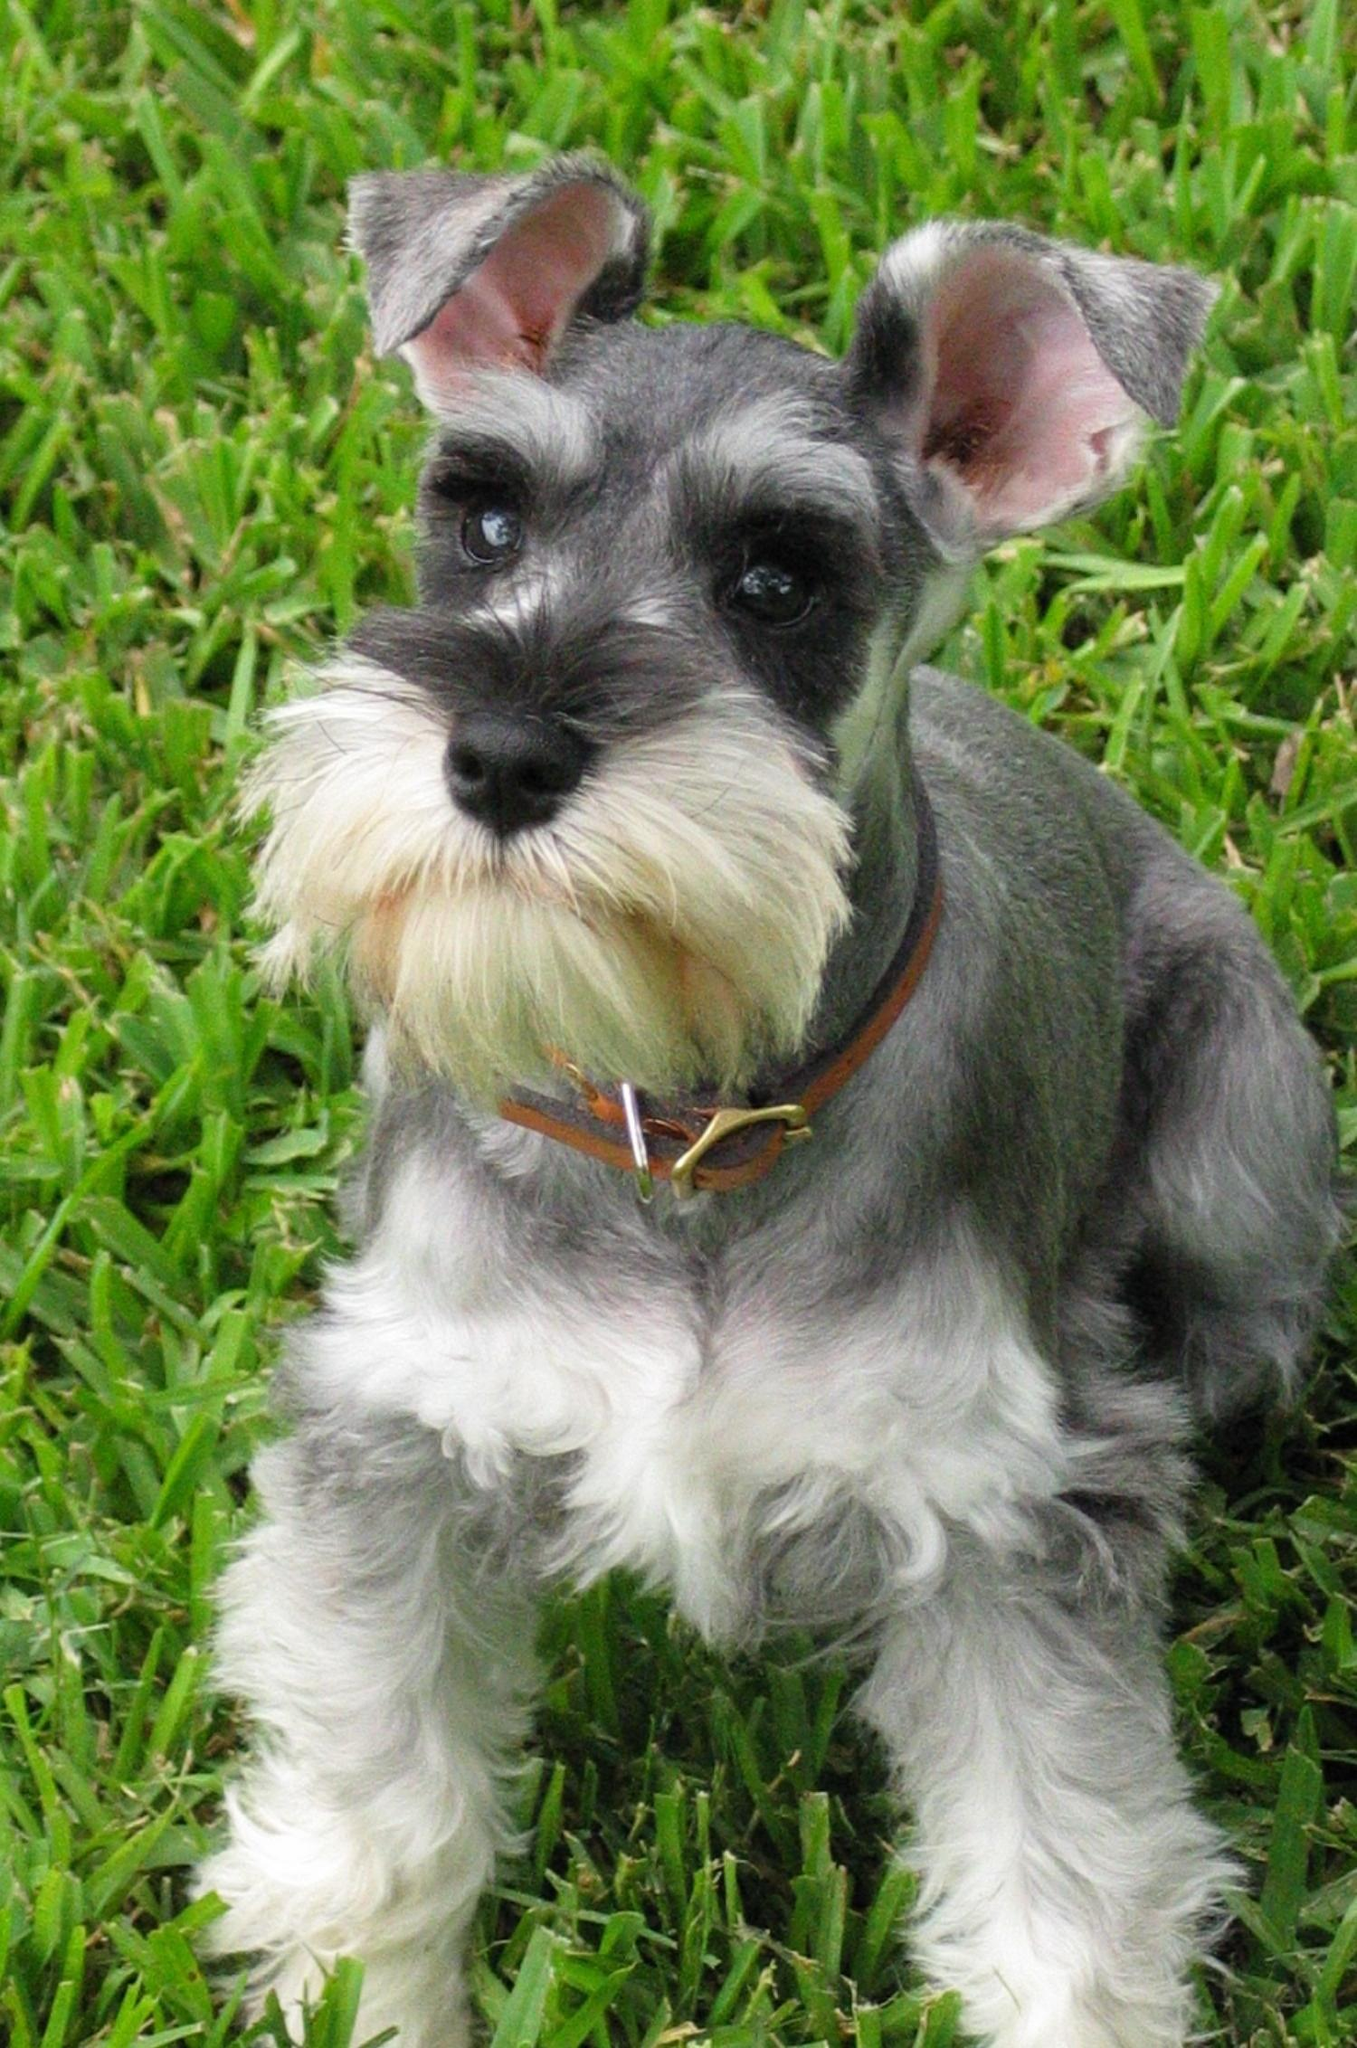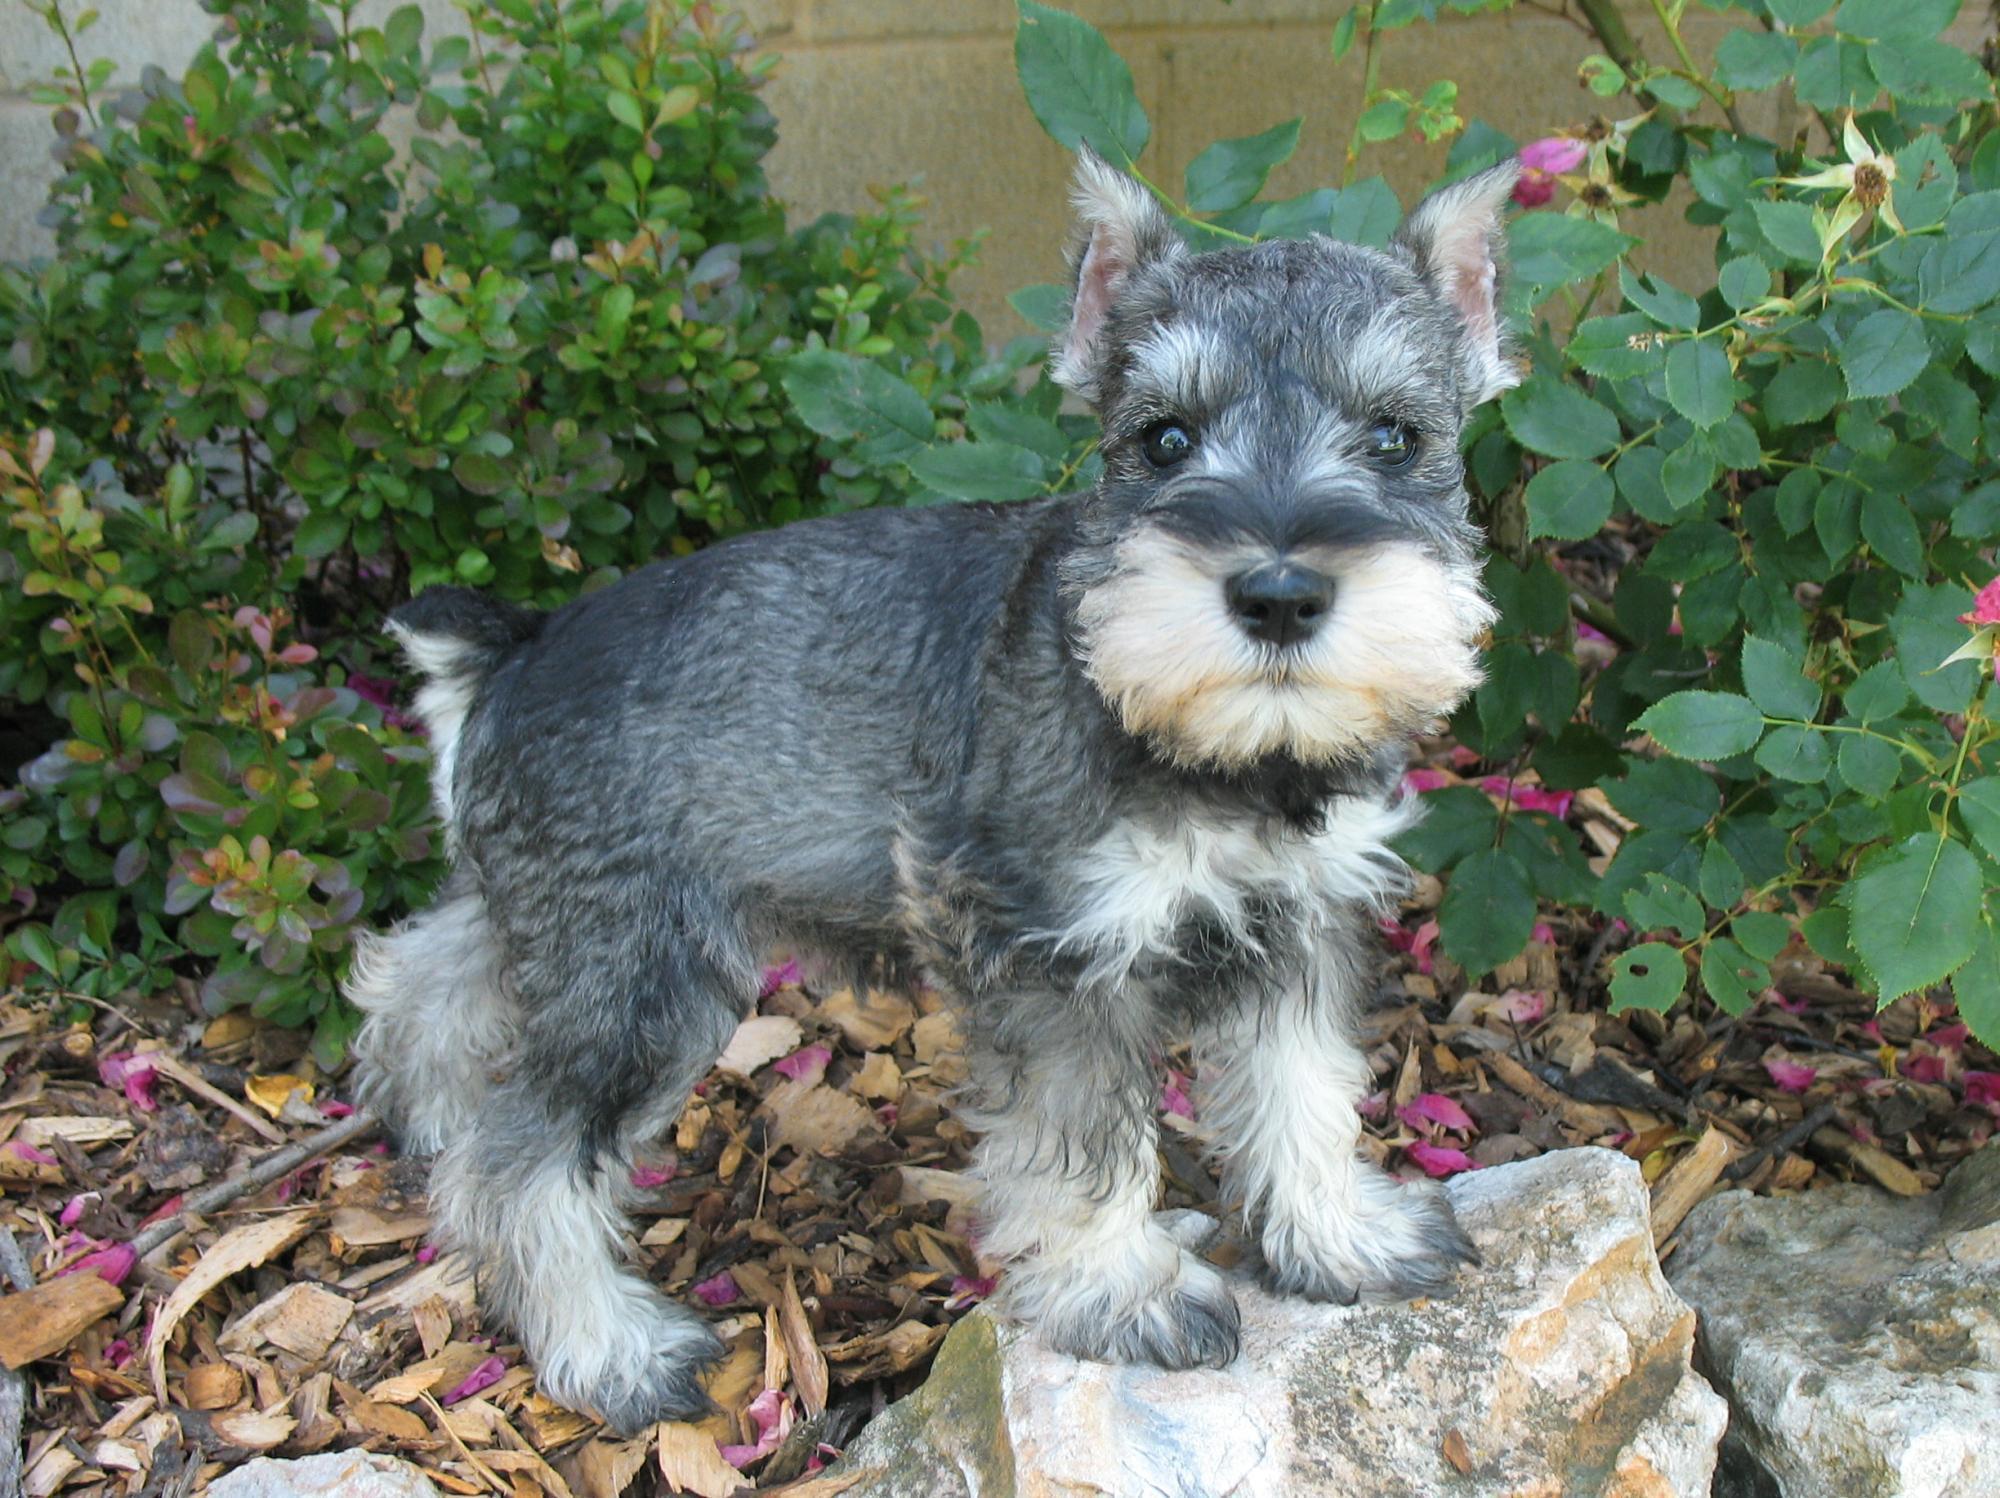The first image is the image on the left, the second image is the image on the right. Examine the images to the left and right. Is the description "In one image there is a dog sitting in grass." accurate? Answer yes or no. Yes. The first image is the image on the left, the second image is the image on the right. Examine the images to the left and right. Is the description "The right image has a dog with it's from feet propped on stone while looking at the camera" accurate? Answer yes or no. Yes. 